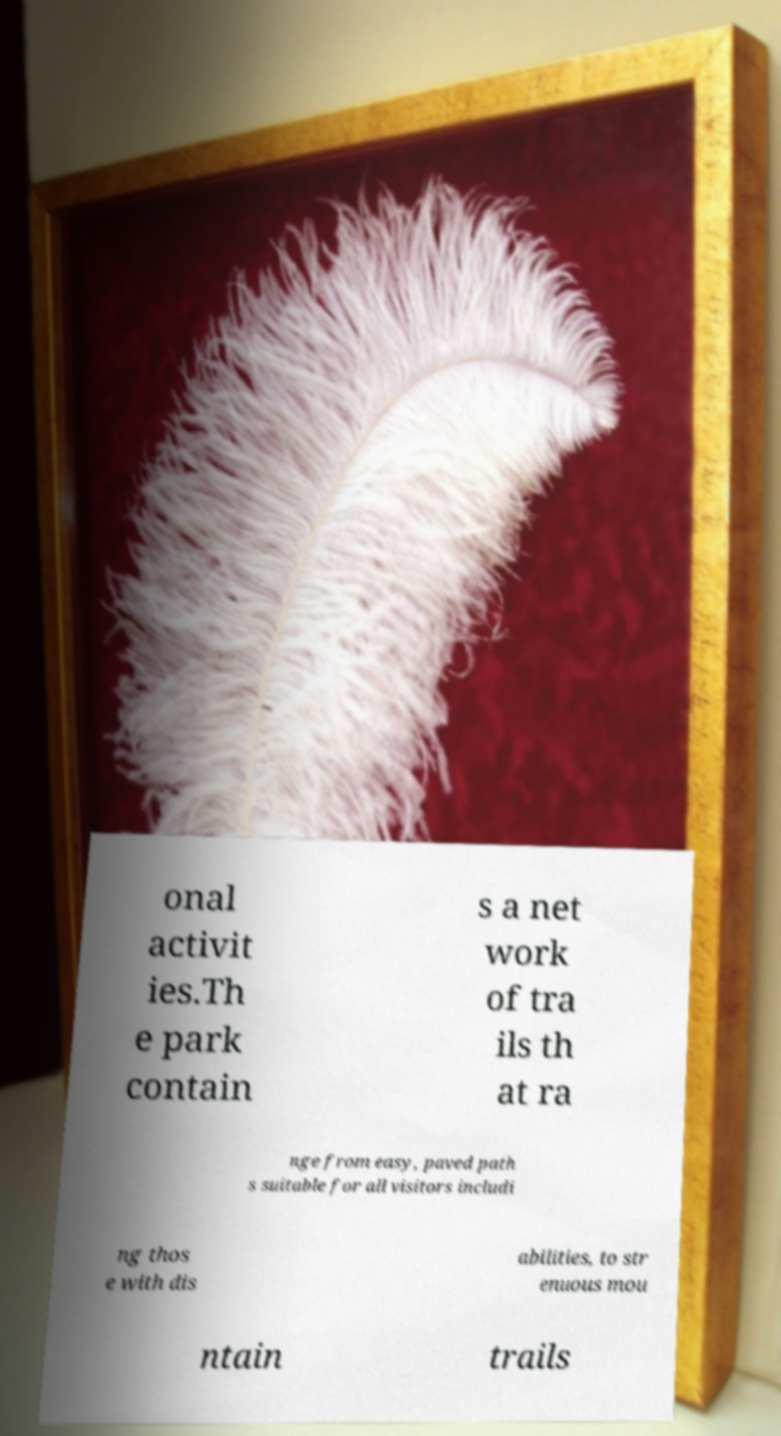Please identify and transcribe the text found in this image. onal activit ies.Th e park contain s a net work of tra ils th at ra nge from easy, paved path s suitable for all visitors includi ng thos e with dis abilities, to str enuous mou ntain trails 